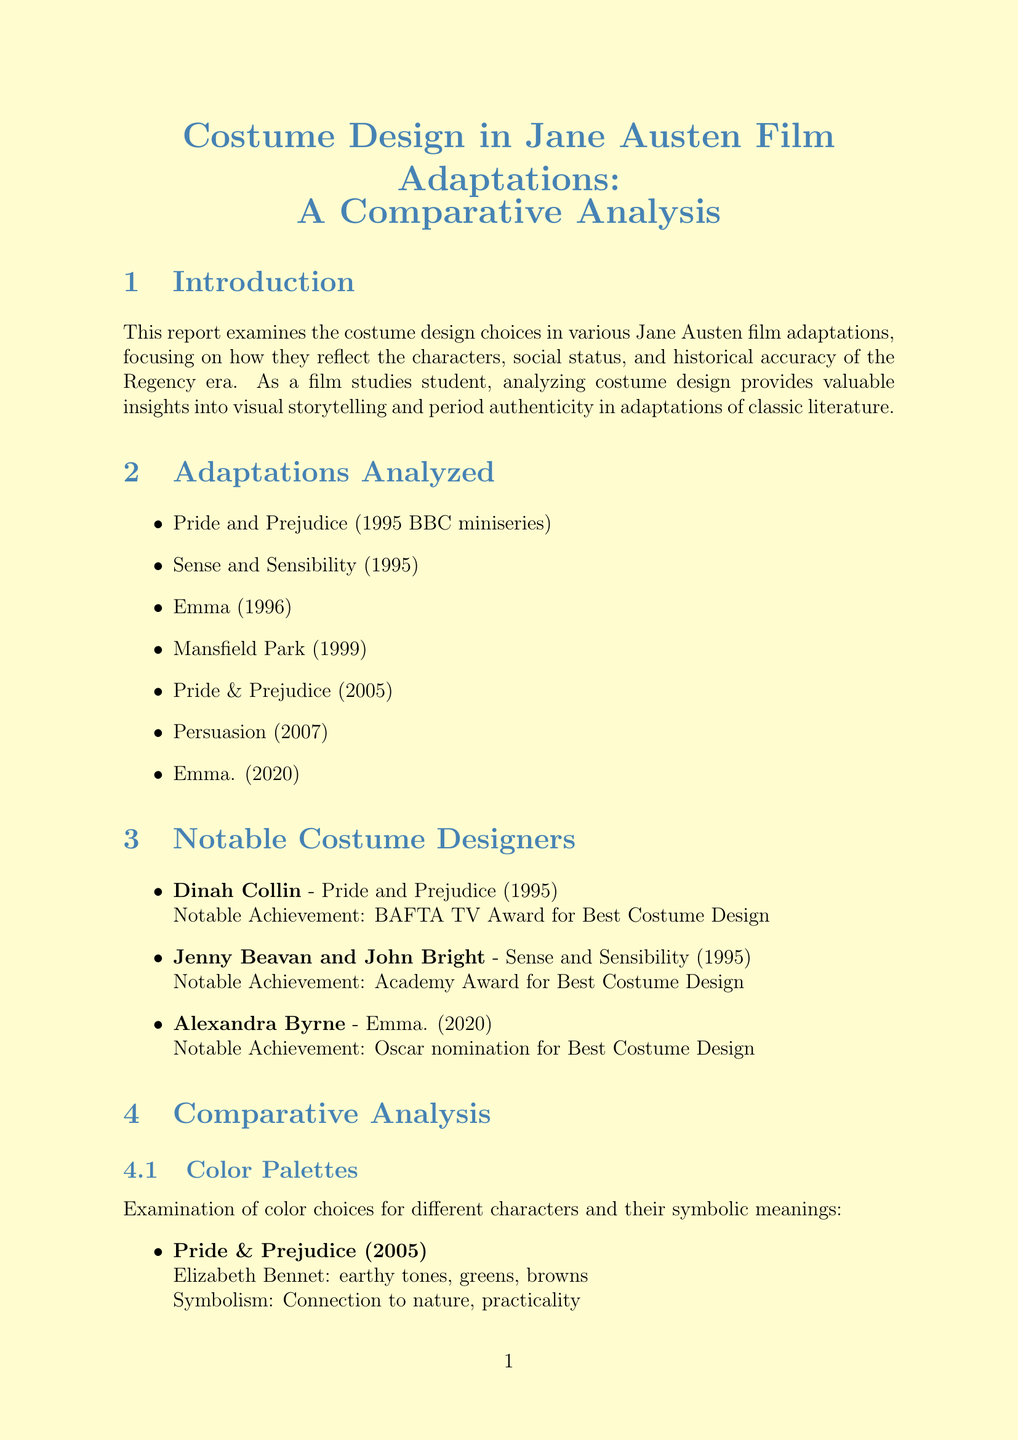What is the title of the report? The title of the report is provided at the beginning of the document, summarizing its focus on costume design in adaptations of Jane Austen's works.
Answer: Costume Design in Jane Austen Film Adaptations: A Comparative Analysis Who designed the costumes for Sense and Sensibility (1995)? The document lists notable costume designers along with the adaptations they worked on, highlighting Jenny Beavan and John Bright for this title.
Answer: Jenny Beavan and John Bright What is the budget for the Pride & Prejudice (2005) adaptation? A bar chart in the document compares the budgets of different adaptations, providing specific amounts for each.
Answer: £3,500,000 How many adaptations are analyzed in the report? The report explicitly lists the adaptations examined, allowing for a straightforward count of the titles mentioned.
Answer: 7 What is one of the analyzed aspects of historical accuracy? The document outlines various aspects regarding historical accuracy of the costumes based on the Regency era, making the question fairly direct.
Answer: Necklines and sleeve styles Which adaptation received an Oscar nomination for Best Costume Design? The notable achievements section details award nominations and wins, citing Alexandra Byrne's work in this specific adaptation.
Answer: Emma. (2020) Which colors symbolize Emma Woodhouse in Emma (1996)? The comparative analysis section discusses color symbolism for characters, specifically noting the colors associated with Emma Woodhouse.
Answer: pastels, whites, light blues What does the conclusion point out about costume design? The document lists key conclusion points that reflect on costume design's significance in adaptations and its impact.
Answer: The impact of costume design on character development and audience perception 